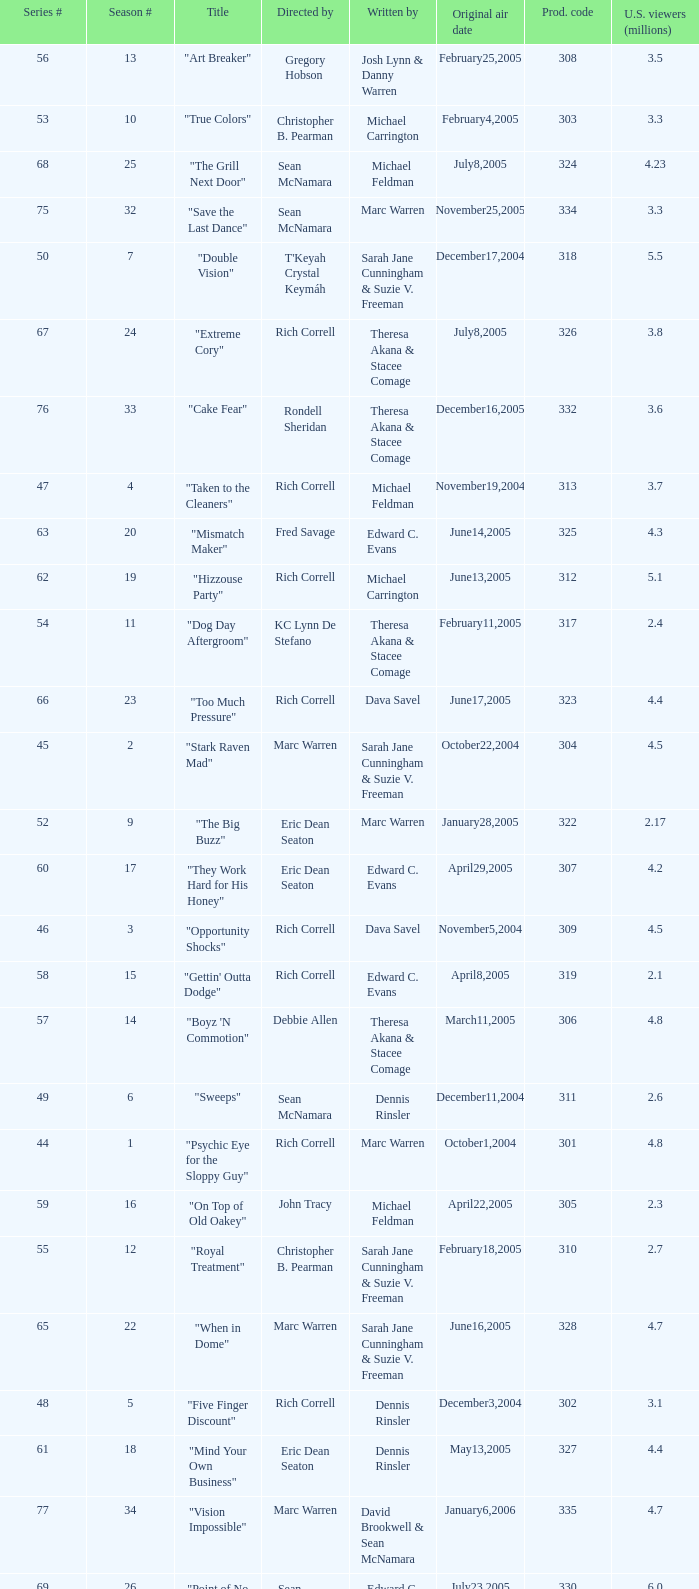What is the title of the episode directed by Rich Correll and written by Dennis Rinsler? "Five Finger Discount". 